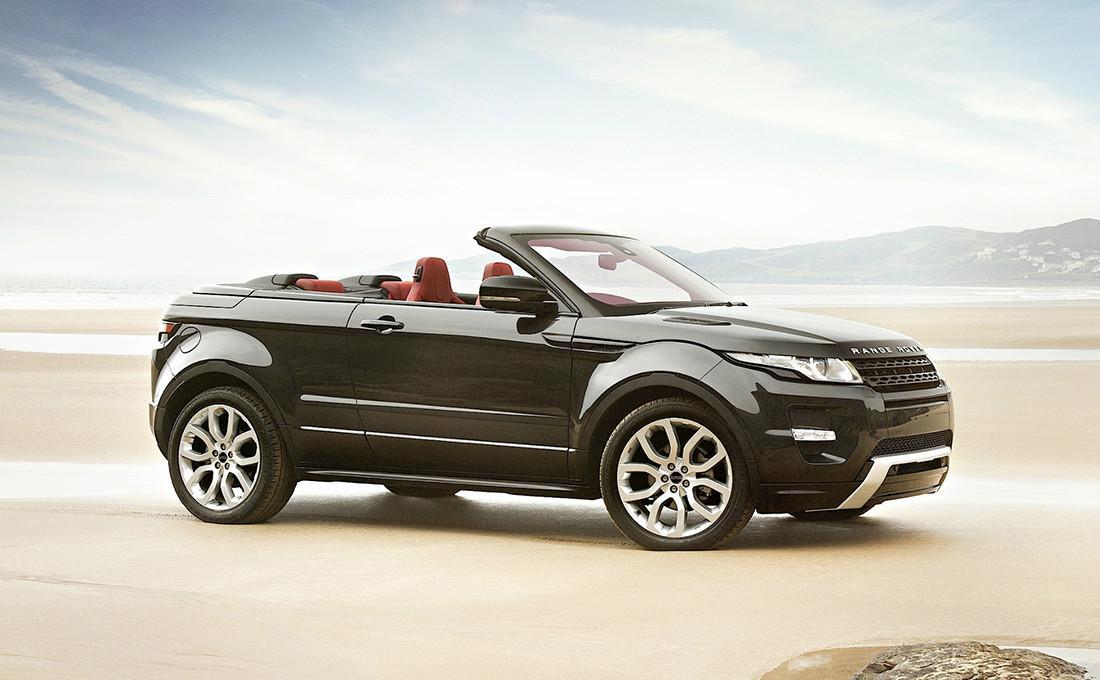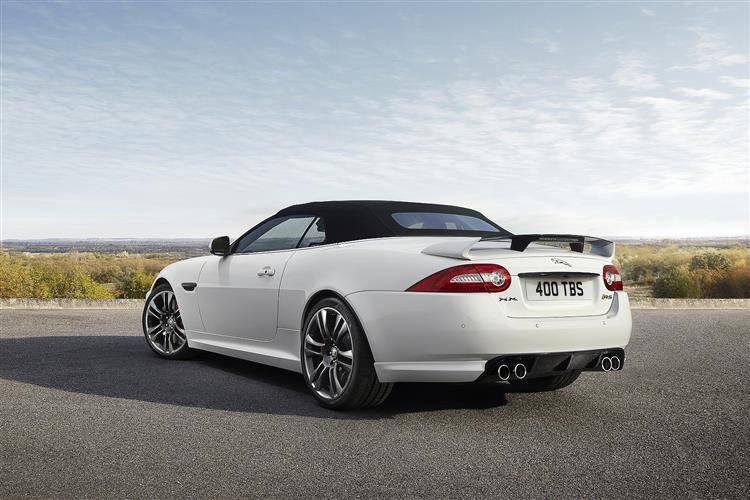The first image is the image on the left, the second image is the image on the right. Examine the images to the left and right. Is the description "The car in one of the images is driving near a snowy location." accurate? Answer yes or no. No. The first image is the image on the left, the second image is the image on the right. For the images displayed, is the sentence "All cars are topless convertibles, and one car is bright orange while the other is white." factually correct? Answer yes or no. No. 